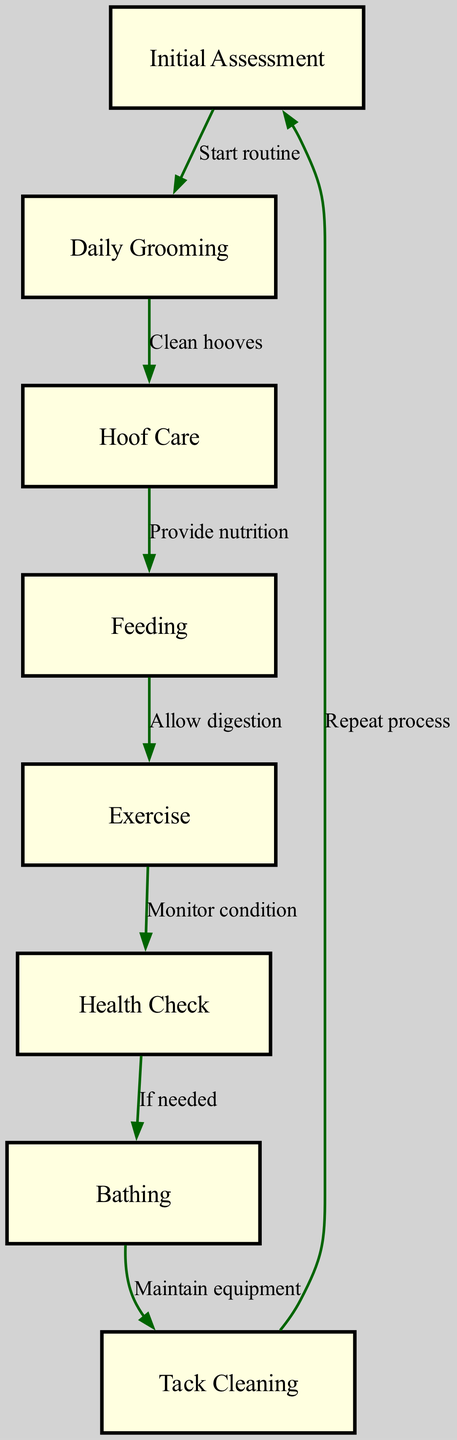What is the first step in the grooming process? The diagram shows that the first node is "Initial Assessment", indicating that this is the starting point of the grooming process.
Answer: Initial Assessment How many nodes are present in the diagram? By counting the listed nodes in the diagram, there are 8 distinct steps outlined in the process flow.
Answer: 8 What action follows "Daily Grooming"? The diagram indicates that after "Daily Grooming", the next step leads to "Hoof Care", showcasing the flow from grooming to hoof maintenance.
Answer: Hoof Care What must occur before exercise? According to the diagram, "Feeding" must occur before "Exercise", as the edges indicate sequential tasks that need to be followed for proper care.
Answer: Feeding What is the relationship between "Health Check" and "Bathing"? The diagram states that "Health Check" leads to "Bathing", but only if necessary, illustrating that the health condition of the horse influences this decision.
Answer: If needed What step follows "Tack Cleaning"? The directed graph shows that after "Tack Cleaning", the flow returns to "Initial Assessment", indicating a cyclical nature in the grooming process.
Answer: Initial Assessment How many edges connect the nodes in the diagram? Counting the edges that represent the transitions from one node to another reveals that there are 8 edges present in the directed graph.
Answer: 8 Which step requires monitoring the horse’s condition? The diagram clearly indicates that "Exercise" leads to "Health Check", where monitoring the horse’s condition is essential to determine its health status.
Answer: Monitor condition What does "Bathing" depend on? According to the diagram, "Bathing" is contingent upon the result of the "Health Check", specifically noted as "If needed", clarifying that bathing is not always necessary.
Answer: If needed 